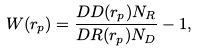Convert formula to latex. <formula><loc_0><loc_0><loc_500><loc_500>W ( r _ { p } ) = \frac { D D ( r _ { p } ) N _ { R } } { D R ( r _ { p } ) N _ { D } } - 1 ,</formula> 